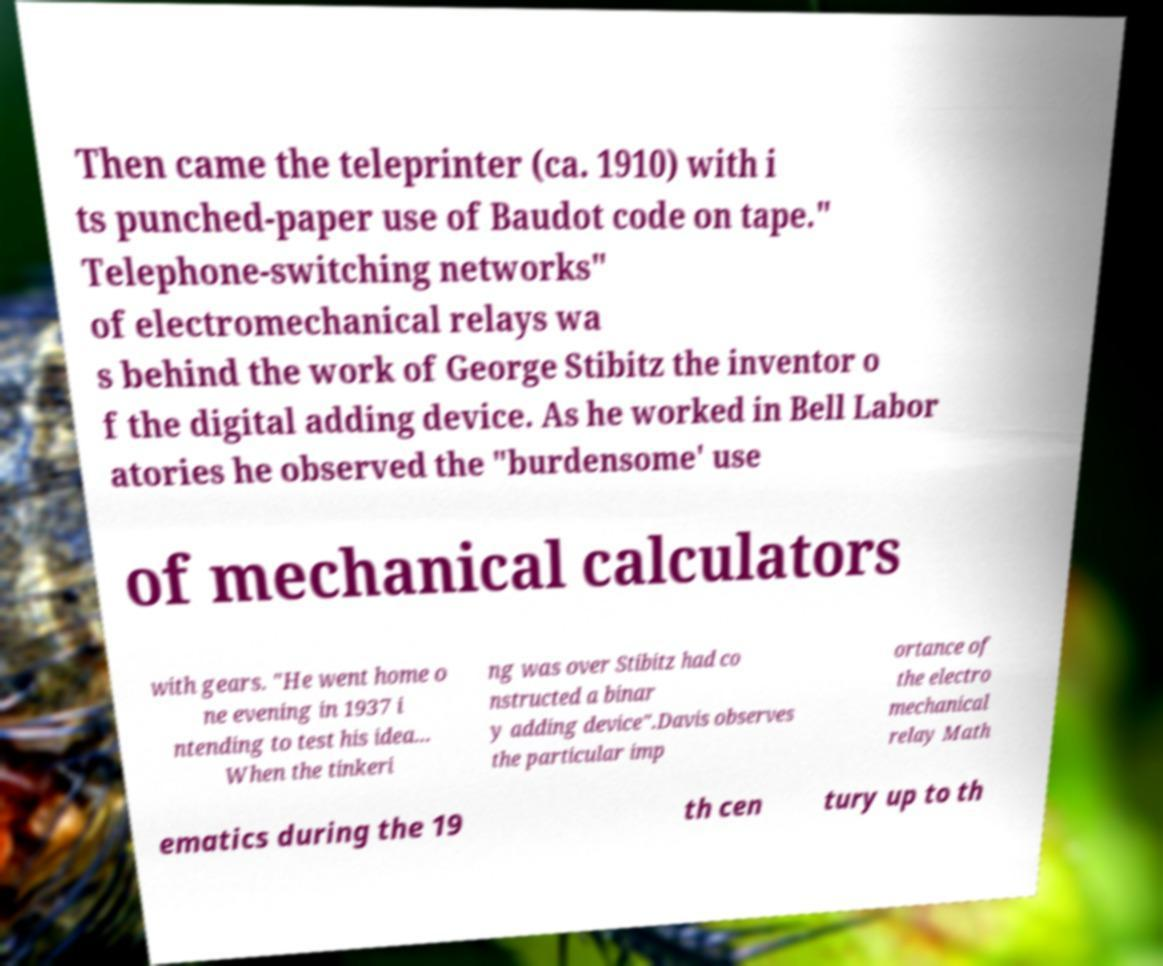For documentation purposes, I need the text within this image transcribed. Could you provide that? Then came the teleprinter (ca. 1910) with i ts punched-paper use of Baudot code on tape." Telephone-switching networks" of electromechanical relays wa s behind the work of George Stibitz the inventor o f the digital adding device. As he worked in Bell Labor atories he observed the "burdensome' use of mechanical calculators with gears. "He went home o ne evening in 1937 i ntending to test his idea... When the tinkeri ng was over Stibitz had co nstructed a binar y adding device".Davis observes the particular imp ortance of the electro mechanical relay Math ematics during the 19 th cen tury up to th 